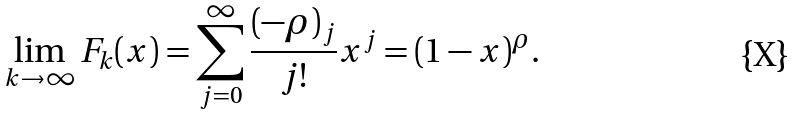Convert formula to latex. <formula><loc_0><loc_0><loc_500><loc_500>\lim _ { k \to \infty } F _ { k } ( x ) = \sum _ { j = 0 } ^ { \infty } \frac { ( - \rho ) _ { j } } { j ! } x ^ { j } = ( 1 - x ) ^ { \rho } .</formula> 